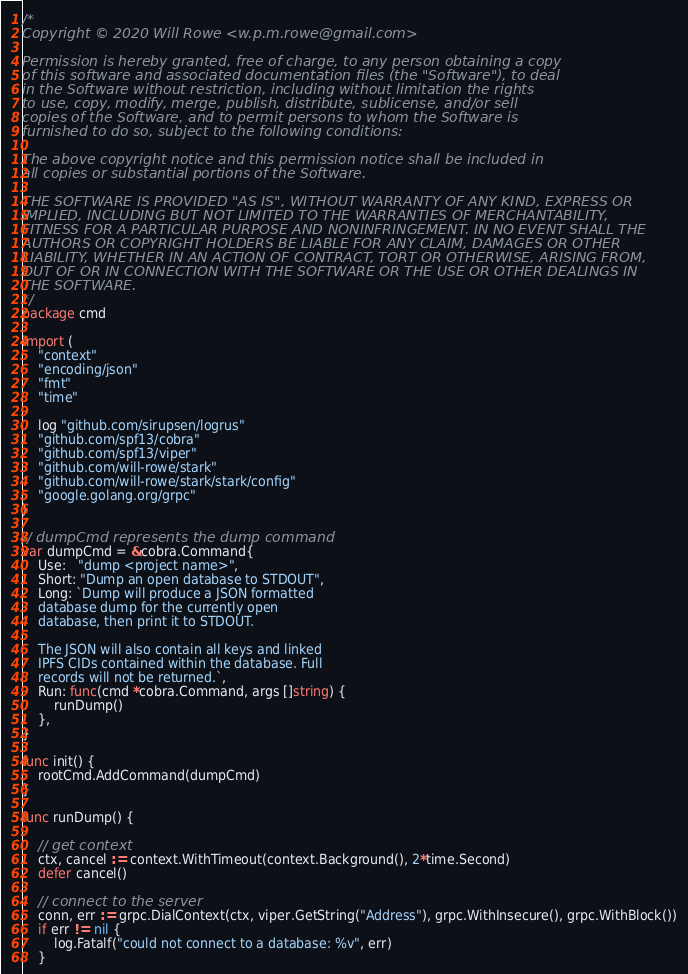Convert code to text. <code><loc_0><loc_0><loc_500><loc_500><_Go_>/*
Copyright © 2020 Will Rowe <w.p.m.rowe@gmail.com>

Permission is hereby granted, free of charge, to any person obtaining a copy
of this software and associated documentation files (the "Software"), to deal
in the Software without restriction, including without limitation the rights
to use, copy, modify, merge, publish, distribute, sublicense, and/or sell
copies of the Software, and to permit persons to whom the Software is
furnished to do so, subject to the following conditions:

The above copyright notice and this permission notice shall be included in
all copies or substantial portions of the Software.

THE SOFTWARE IS PROVIDED "AS IS", WITHOUT WARRANTY OF ANY KIND, EXPRESS OR
IMPLIED, INCLUDING BUT NOT LIMITED TO THE WARRANTIES OF MERCHANTABILITY,
FITNESS FOR A PARTICULAR PURPOSE AND NONINFRINGEMENT. IN NO EVENT SHALL THE
AUTHORS OR COPYRIGHT HOLDERS BE LIABLE FOR ANY CLAIM, DAMAGES OR OTHER
LIABILITY, WHETHER IN AN ACTION OF CONTRACT, TORT OR OTHERWISE, ARISING FROM,
OUT OF OR IN CONNECTION WITH THE SOFTWARE OR THE USE OR OTHER DEALINGS IN
THE SOFTWARE.
*/
package cmd

import (
	"context"
	"encoding/json"
	"fmt"
	"time"

	log "github.com/sirupsen/logrus"
	"github.com/spf13/cobra"
	"github.com/spf13/viper"
	"github.com/will-rowe/stark"
	"github.com/will-rowe/stark/stark/config"
	"google.golang.org/grpc"
)

// dumpCmd represents the dump command
var dumpCmd = &cobra.Command{
	Use:   "dump <project name>",
	Short: "Dump an open database to STDOUT",
	Long: `Dump will produce a JSON formatted
	database dump for the currently open 
	database, then print it to STDOUT.
	
	The JSON will also contain all keys and linked
	IPFS CIDs contained within the database. Full
	records will not be returned.`,
	Run: func(cmd *cobra.Command, args []string) {
		runDump()
	},
}

func init() {
	rootCmd.AddCommand(dumpCmd)
}

func runDump() {

	// get context
	ctx, cancel := context.WithTimeout(context.Background(), 2*time.Second)
	defer cancel()

	// connect to the server
	conn, err := grpc.DialContext(ctx, viper.GetString("Address"), grpc.WithInsecure(), grpc.WithBlock())
	if err != nil {
		log.Fatalf("could not connect to a database: %v", err)
	}</code> 